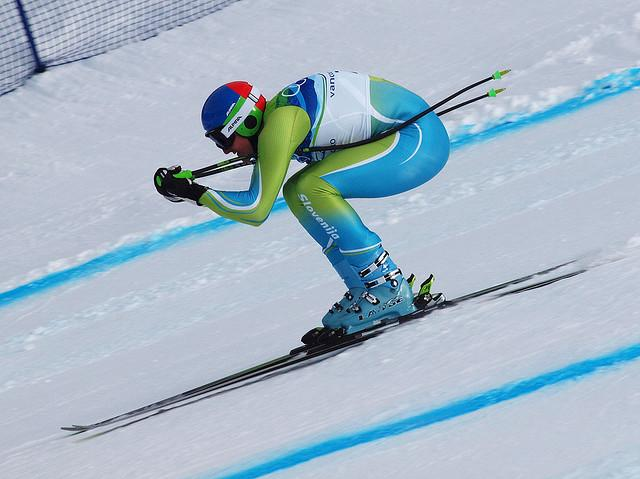What is this person trying to do? ski 